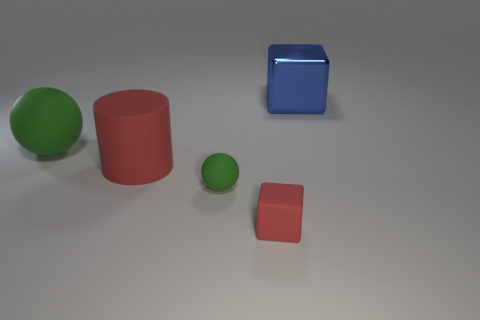Is the shape of the blue shiny thing the same as the small red object? The blue object and the small red object both have a cubic shape, featuring six faces with right angles and equal-sized edges. 